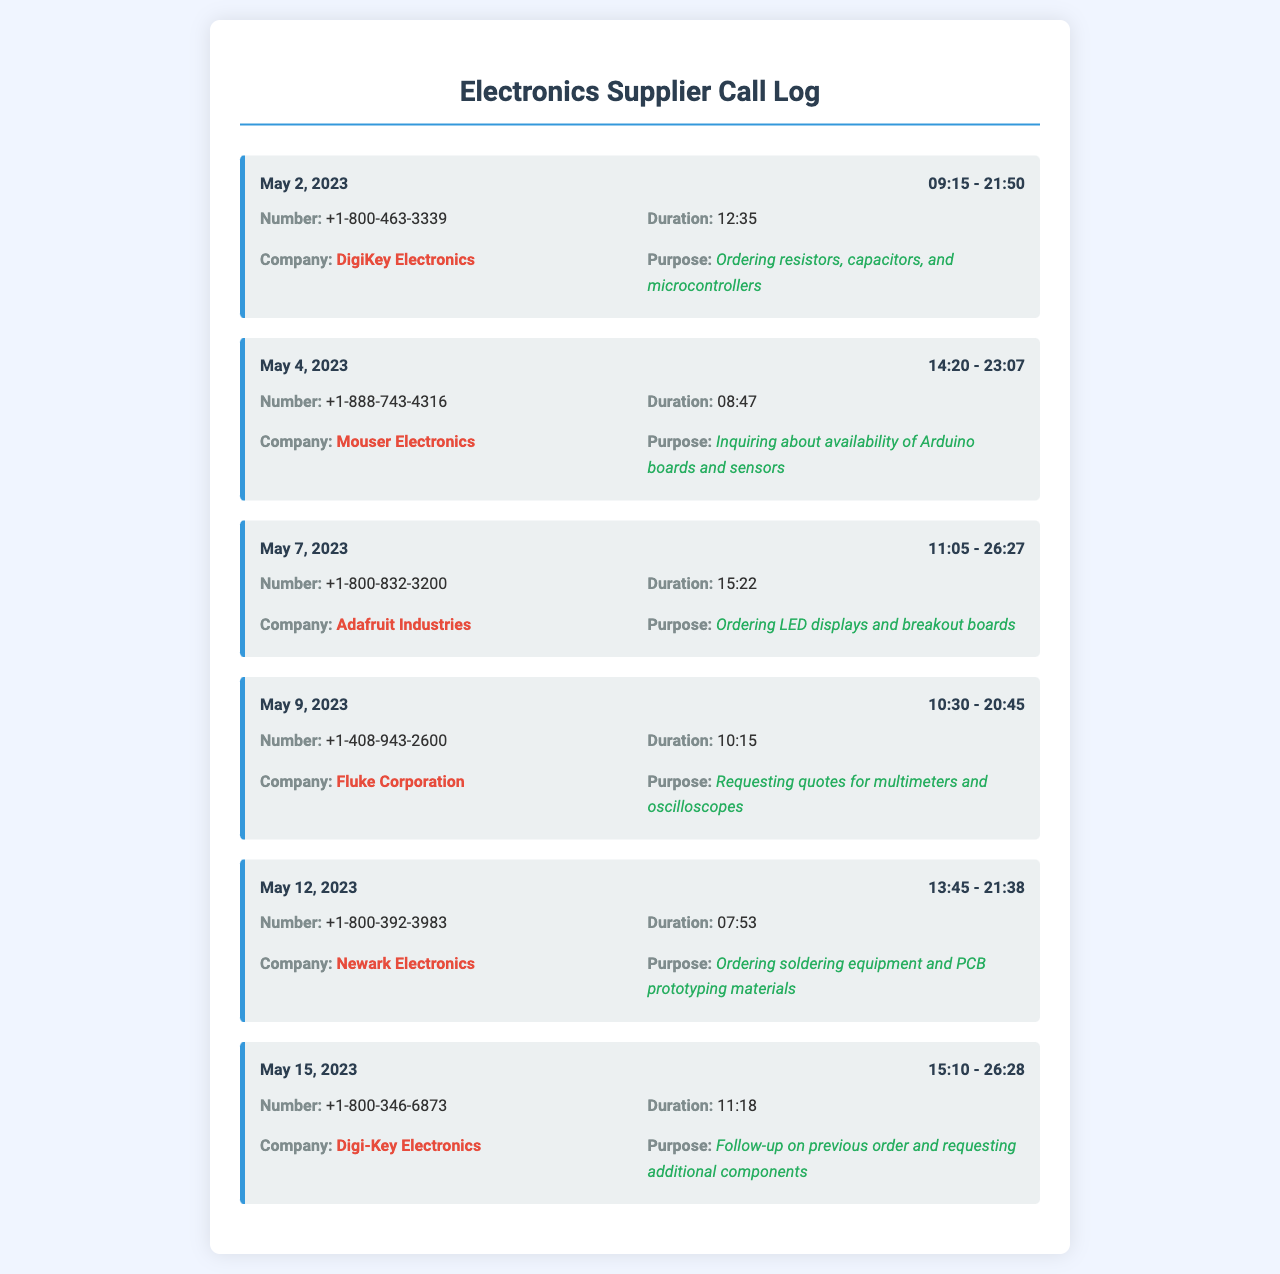What is the date of the call to DigiKey Electronics? The date of the call is specified in the first record under the company DigiKey Electronics, which is May 2, 2023.
Answer: May 2, 2023 How long was the call to Mouser Electronics? The duration of the call is listed in the record for Mouser Electronics, which is 08:47.
Answer: 08:47 What components were ordered from Adafruit Industries? The purpose of the call provides specific information about the components ordered, which are LED displays and breakout boards.
Answer: LED displays and breakout boards What is the phone number for Newark Electronics? The phone number is found in the respective record and is +1-800-392-3983.
Answer: +1-800-392-3983 Which company was called to inquire about Arduino boards? This information can be found in the purpose section of the Mouser Electronics record, which mentions inquiring about Arduino boards.
Answer: Mouser Electronics What time did the call to Fluke Corporation start? The start time is listed in the record for Fluke Corporation, which is 10:30.
Answer: 10:30 Which company had the longest call duration? By comparing the durations across different records, the longest call duration was to Digi-Key Electronics on May 15, 2023, lasting 11:18.
Answer: Digi-Key Electronics What was the purpose of the call on May 12, 2023? The purpose is described in the record for that date, indicating ordering soldering equipment and PCB prototyping materials.
Answer: Ordering soldering equipment and PCB prototyping materials 